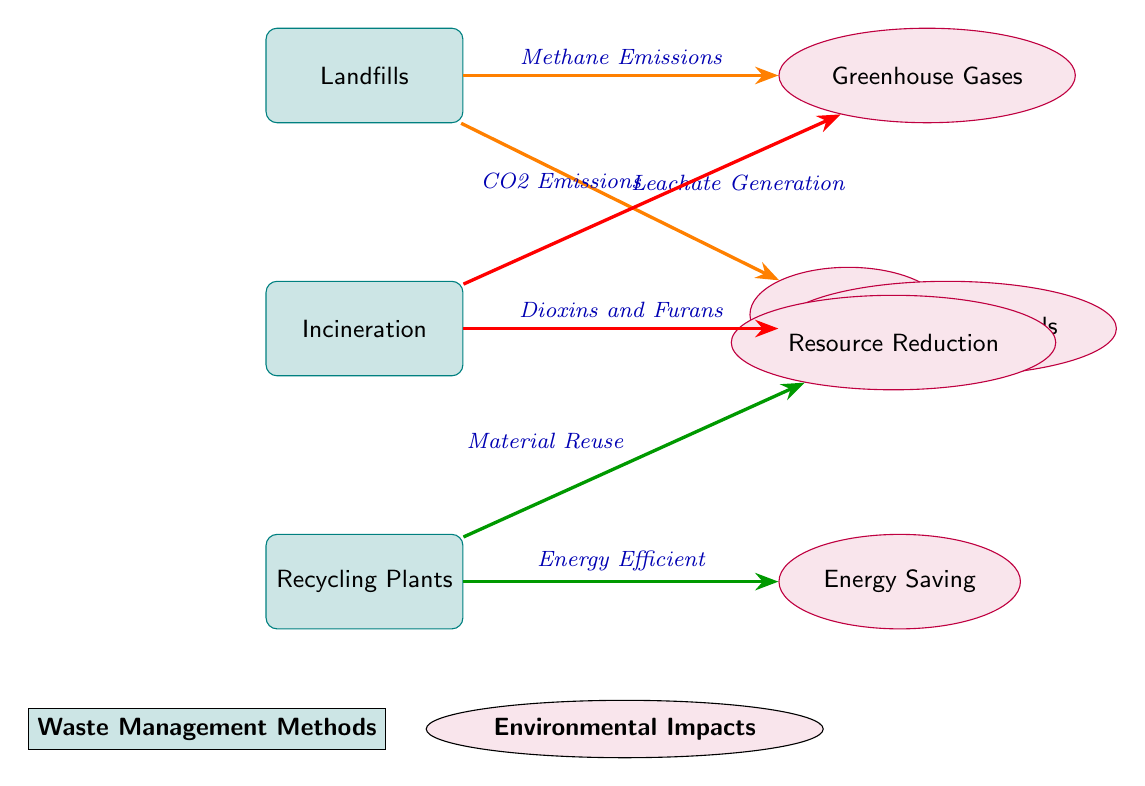What are the three waste management methods shown in the diagram? The diagram clearly lists three methods: Landfills, Incineration, and Recycling Plants.
Answer: Landfills, Incineration, Recycling Plants Which environmental impact is associated with Landfills? The diagram shows two environmental impacts linked to Landfills: Greenhouse Gases and Leachate. Both impacts are visually directed from the Landfills method node.
Answer: Greenhouse Gases, Leachate How many environmental impacts are listed for Incineration? The diagram shows two impacts from Incineration: CO2 Emissions and Harmful Compounds. Thus, the count of impacts visually linked to this method is two.
Answer: 2 What type of emissions does Incineration produce? From the diagram, the two specific emissions associated with Incineration are CO2 Emissions and Dioxins and Furans, indicating the harmful nature of this waste management method.
Answer: CO2 Emissions, Dioxins and Furans Which waste management method is linked to Resource Reduction? The diagram indicates that Resource Reduction is an environmental impact resulting from Recycling Plants, showing a clear connection from this method to that impact.
Answer: Recycling Plants Which waste management method produces Methane Emissions? The diagram shows a direct connection between the Landfills method and Methane Emissions, indicating that Landfills are responsible for this type of emissions.
Answer: Landfills Which two environmental impacts are associated with Recycling Plants? The diagram highlights two impacts from Recycling Plants: Resource Reduction and Energy Saving, linking both impacts visually from the Recycling Plants node.
Answer: Resource Reduction, Energy Saving Which method is likely to lead to harmful compounds? According to the diagram, Incineration is the method that leads to the emission of harmful compounds, which are listed in association with its impacts.
Answer: Incineration What color represents Waste Management Methods in the diagram? The legend in the diagram distinguishes Waste Management Methods by a teal color, clearly indicating the visual separation from environmental impacts.
Answer: Teal 